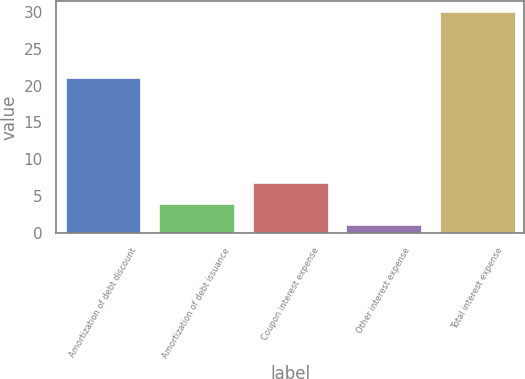Convert chart. <chart><loc_0><loc_0><loc_500><loc_500><bar_chart><fcel>Amortization of debt discount<fcel>Amortization of debt issuance<fcel>Coupon interest expense<fcel>Other interest expense<fcel>Total interest expense<nl><fcel>21<fcel>3.9<fcel>6.8<fcel>1<fcel>30<nl></chart> 